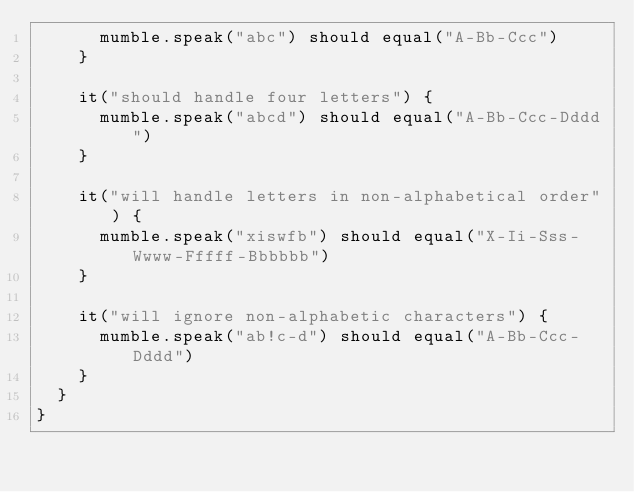Convert code to text. <code><loc_0><loc_0><loc_500><loc_500><_Scala_>      mumble.speak("abc") should equal("A-Bb-Ccc")
    }

    it("should handle four letters") {
      mumble.speak("abcd") should equal("A-Bb-Ccc-Dddd")
    }

    it("will handle letters in non-alphabetical order") {
      mumble.speak("xiswfb") should equal("X-Ii-Sss-Wwww-Fffff-Bbbbbb")
    }

    it("will ignore non-alphabetic characters") {
      mumble.speak("ab!c-d") should equal("A-Bb-Ccc-Dddd")
    }
  }
}
</code> 